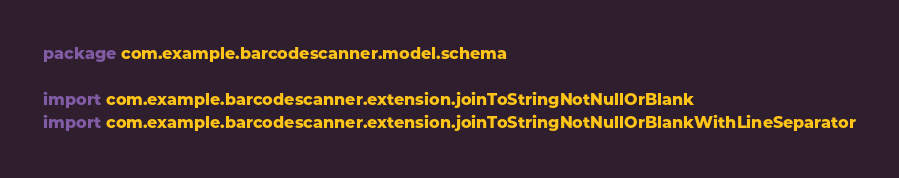<code> <loc_0><loc_0><loc_500><loc_500><_Kotlin_>package com.example.barcodescanner.model.schema

import com.example.barcodescanner.extension.joinToStringNotNullOrBlank
import com.example.barcodescanner.extension.joinToStringNotNullOrBlankWithLineSeparator</code> 